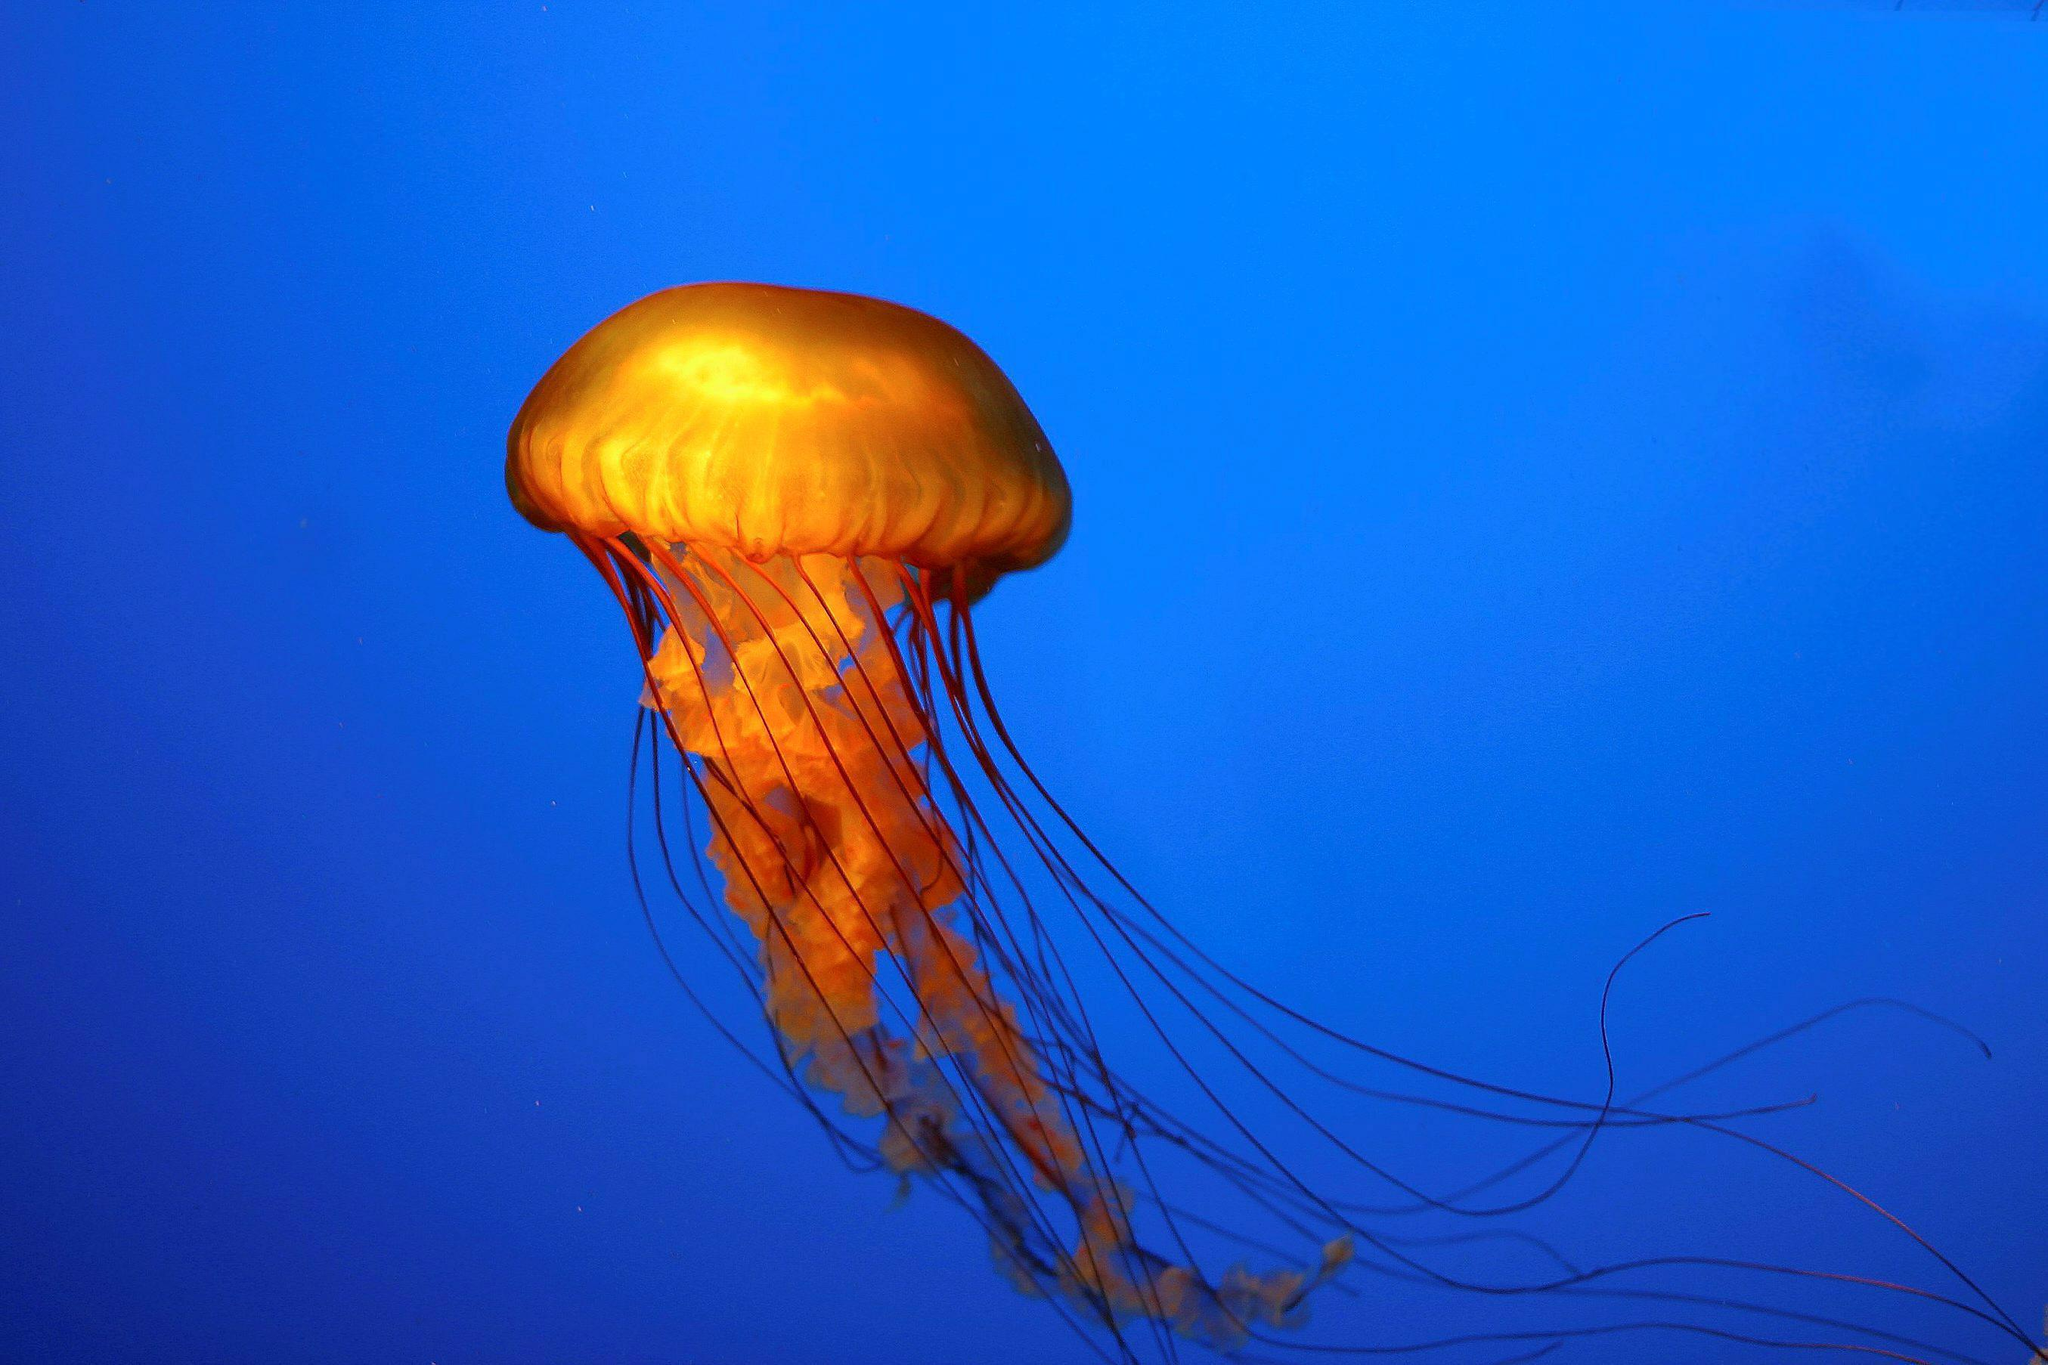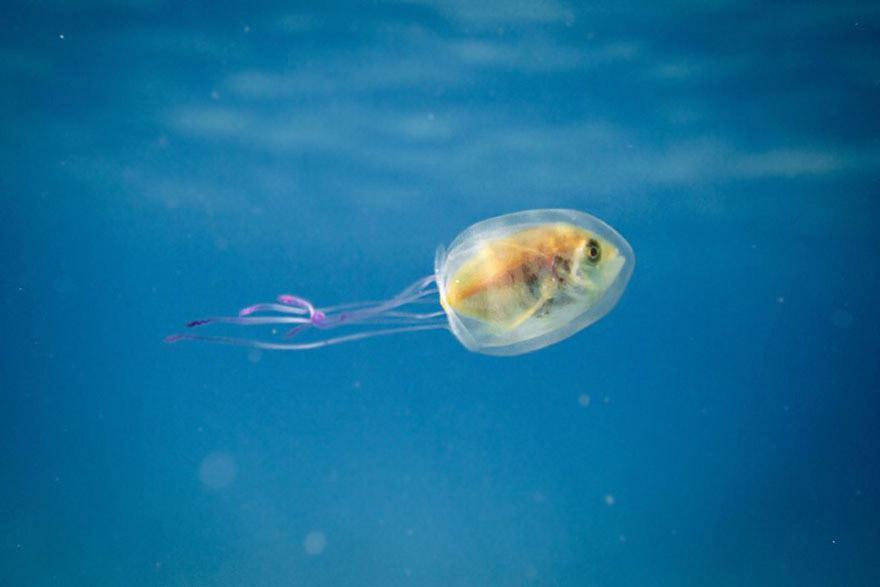The first image is the image on the left, the second image is the image on the right. For the images shown, is this caption "The left image includes at least one orange jellyfish with long tentacles, and the right image features a fish visible inside a translucent jellyfish." true? Answer yes or no. Yes. The first image is the image on the left, the second image is the image on the right. Evaluate the accuracy of this statement regarding the images: "One of the images shows one jellyfish with a fish inside and nothing else.". Is it true? Answer yes or no. Yes. 